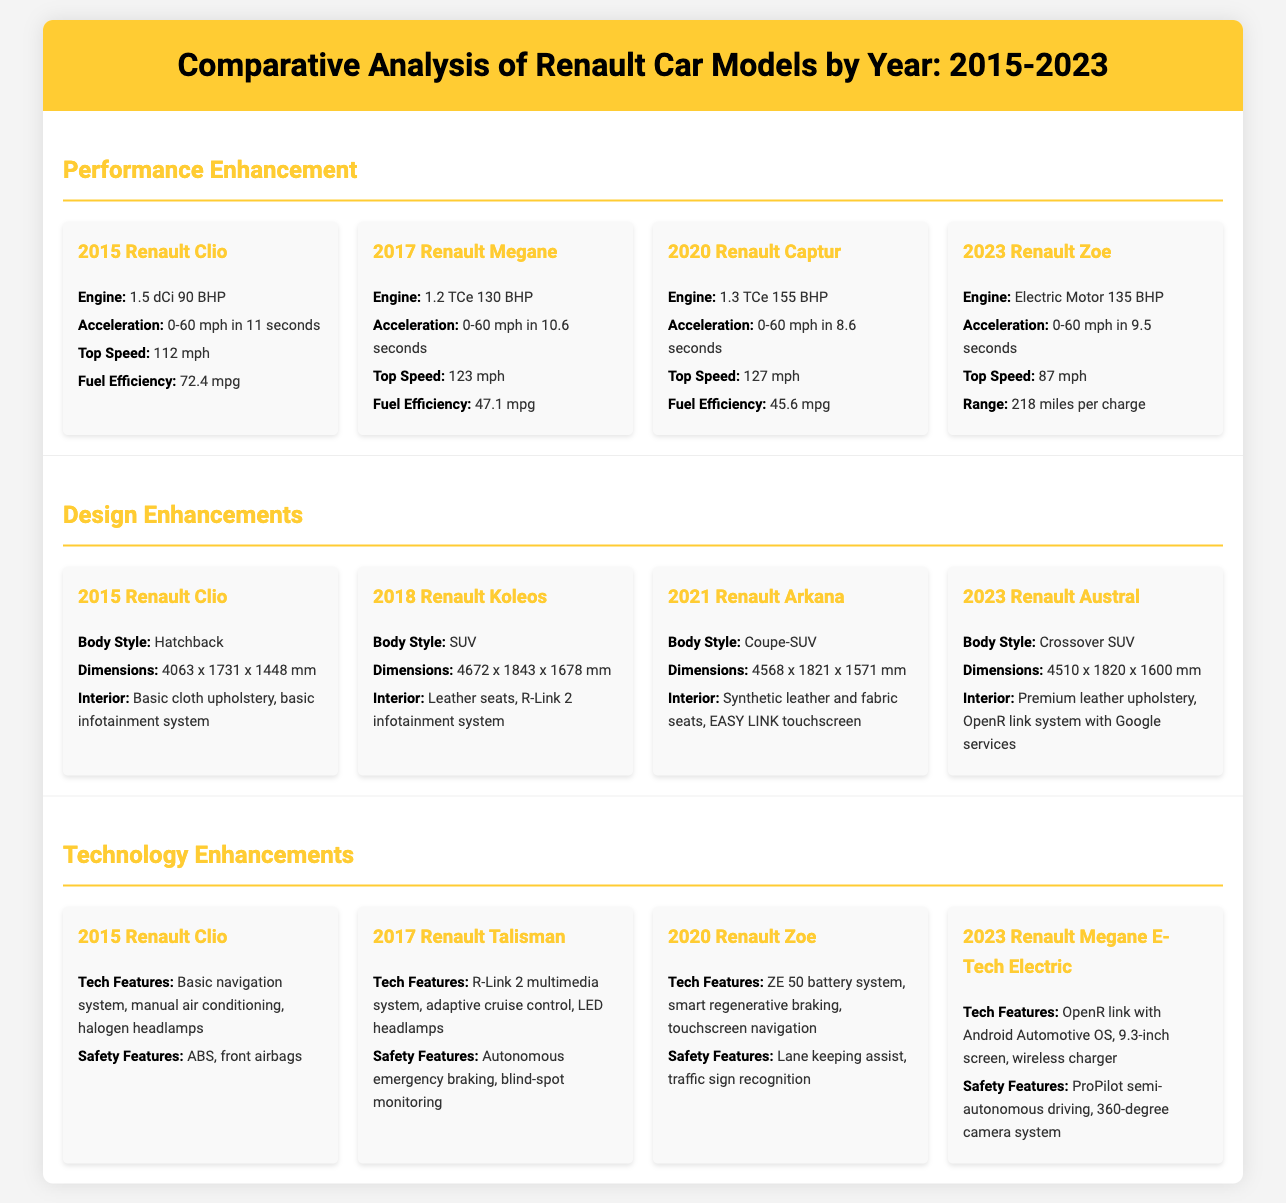what is the engine type of the 2023 Renault Zoe? The engine type of the 2023 Renault Zoe is mentioned as an electric motor with 135 BHP.
Answer: Electric Motor 135 BHP what was the top speed of the 2017 Renault Megane? The top speed of the 2017 Renault Megane is stated to be 123 mph.
Answer: 123 mph which Renault model introduced in 2021 has a coupe-SUV body style? The Renault model introduced in 2021 with a coupe-SUV body style is the Renault Arkana.
Answer: Renault Arkana what is the fuel efficiency of the 2015 Renault Clio? The fuel efficiency of the 2015 Renault Clio is specified as 72.4 mpg.
Answer: 72.4 mpg how many inches is the screen size of the 2023 Renault Megane E-Tech Electric? The screen size of the 2023 Renault Megane E-Tech Electric is mentioned as 9.3 inches.
Answer: 9.3-inch screen which model has the fastest acceleration? The Renault Captur from 2020 has the fastest acceleration, achieving 0-60 mph in 8.6 seconds.
Answer: 2020 Renault Captur what safety feature was added in the 2017 Renault Talisman? The 2017 Renault Talisman includes autonomous emergency braking as a safety feature.
Answer: Autonomous emergency braking what was unique about the interior of the 2023 Renault Austral? The 2023 Renault Austral features premium leather upholstery and an OpenR link system with Google services in its interior.
Answer: Premium leather upholstery, OpenR link system with Google services what technology feature was introduced with the 2020 Renault Zoe? The 2020 Renault Zoe introduced the ZE 50 battery system as a technology feature.
Answer: ZE 50 battery system 